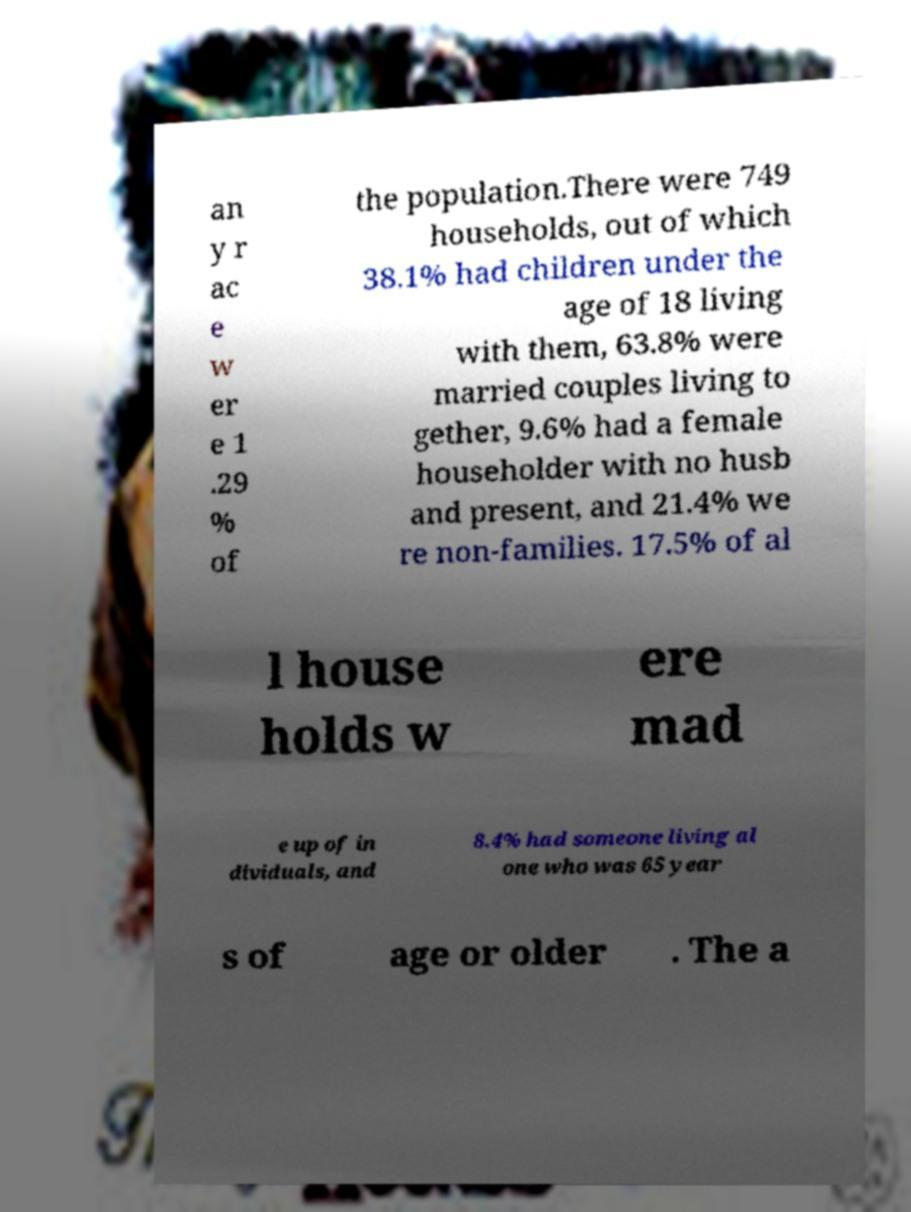Can you accurately transcribe the text from the provided image for me? an y r ac e w er e 1 .29 % of the population.There were 749 households, out of which 38.1% had children under the age of 18 living with them, 63.8% were married couples living to gether, 9.6% had a female householder with no husb and present, and 21.4% we re non-families. 17.5% of al l house holds w ere mad e up of in dividuals, and 8.4% had someone living al one who was 65 year s of age or older . The a 